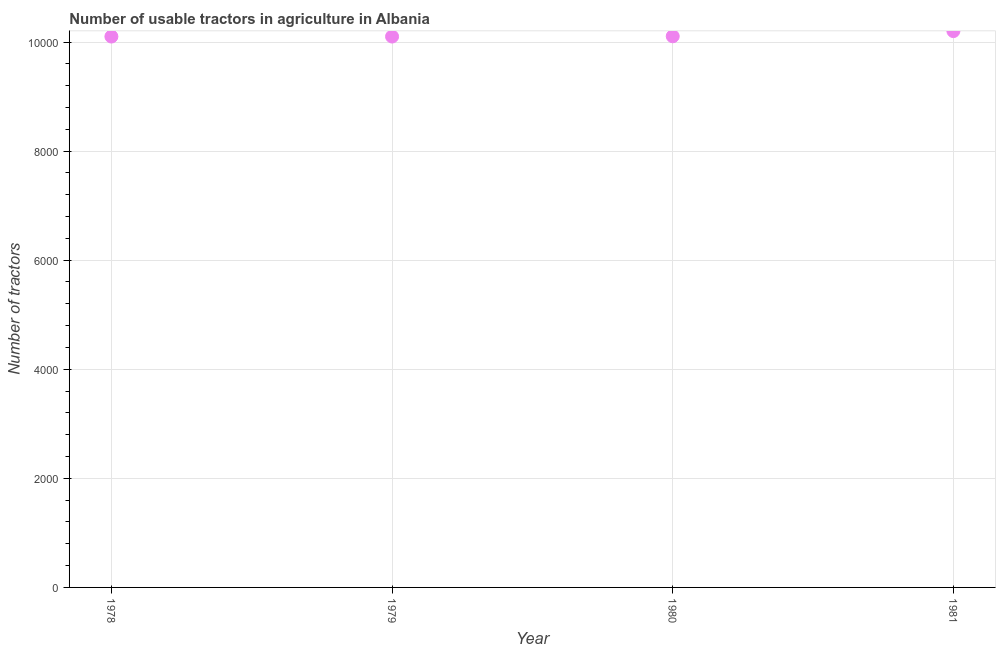What is the number of tractors in 1980?
Offer a very short reply. 1.01e+04. Across all years, what is the maximum number of tractors?
Keep it short and to the point. 1.02e+04. Across all years, what is the minimum number of tractors?
Your answer should be compact. 1.01e+04. In which year was the number of tractors minimum?
Give a very brief answer. 1978. What is the sum of the number of tractors?
Offer a very short reply. 4.05e+04. What is the difference between the number of tractors in 1978 and 1981?
Your response must be concise. -100. What is the average number of tractors per year?
Offer a very short reply. 1.01e+04. What is the median number of tractors?
Your answer should be compact. 1.01e+04. What is the ratio of the number of tractors in 1979 to that in 1981?
Your response must be concise. 0.99. What is the difference between the highest and the lowest number of tractors?
Offer a very short reply. 100. Does the number of tractors monotonically increase over the years?
Provide a short and direct response. No. How many dotlines are there?
Make the answer very short. 1. Does the graph contain grids?
Make the answer very short. Yes. What is the title of the graph?
Ensure brevity in your answer.  Number of usable tractors in agriculture in Albania. What is the label or title of the X-axis?
Offer a very short reply. Year. What is the label or title of the Y-axis?
Provide a short and direct response. Number of tractors. What is the Number of tractors in 1978?
Provide a short and direct response. 1.01e+04. What is the Number of tractors in 1979?
Your response must be concise. 1.01e+04. What is the Number of tractors in 1980?
Your answer should be compact. 1.01e+04. What is the Number of tractors in 1981?
Provide a succinct answer. 1.02e+04. What is the difference between the Number of tractors in 1978 and 1980?
Offer a very short reply. -5. What is the difference between the Number of tractors in 1978 and 1981?
Keep it short and to the point. -100. What is the difference between the Number of tractors in 1979 and 1981?
Your response must be concise. -100. What is the difference between the Number of tractors in 1980 and 1981?
Your response must be concise. -95. What is the ratio of the Number of tractors in 1978 to that in 1981?
Provide a short and direct response. 0.99. What is the ratio of the Number of tractors in 1979 to that in 1980?
Keep it short and to the point. 1. 